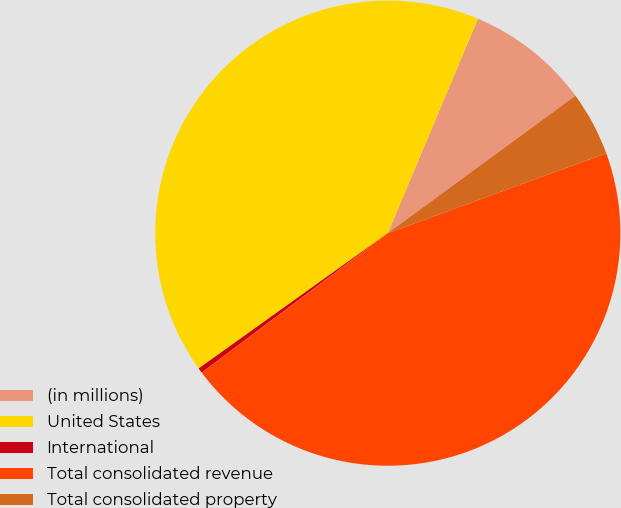Convert chart to OTSL. <chart><loc_0><loc_0><loc_500><loc_500><pie_chart><fcel>(in millions)<fcel>United States<fcel>International<fcel>Total consolidated revenue<fcel>Total consolidated property<nl><fcel>8.6%<fcel>41.22%<fcel>0.35%<fcel>45.35%<fcel>4.48%<nl></chart> 